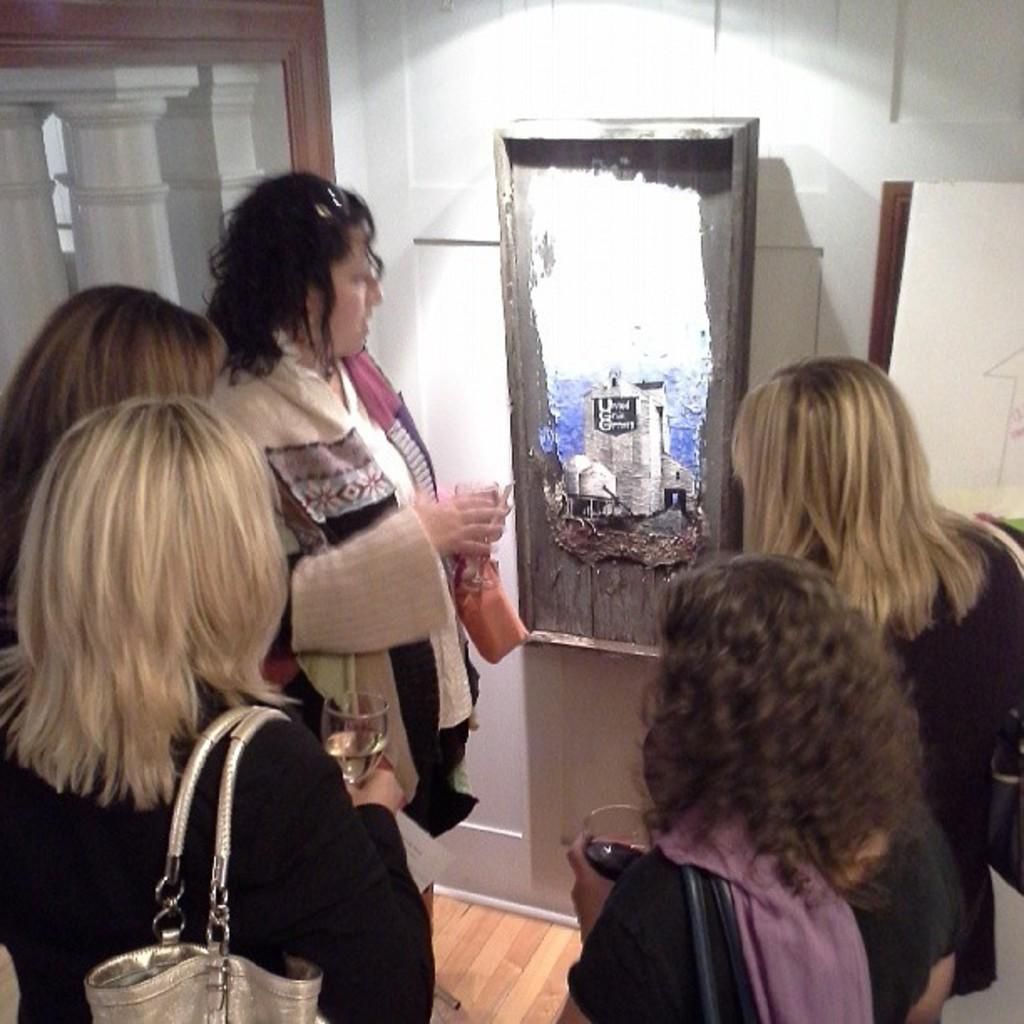Who or what is present in the image? There are people in the image. What are the people doing in the image? The people are standing. What are the people holding in the image? The people are holding glasses. What can be seen in the background of the image? There is a wall in the image. What is on the wall in the image? There are objects on the wall. Where is the horse located in the image? There is no horse present in the image. What type of home is depicted in the image? The image does not depict a home; it only shows people standing with glasses and a wall with objects. 